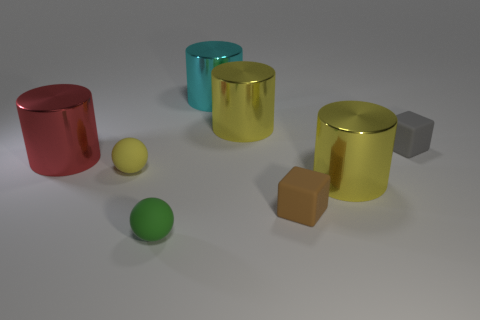There is a thing that is both in front of the tiny yellow object and on the right side of the brown block; what size is it?
Provide a short and direct response. Large. Are the green ball and the tiny yellow thing made of the same material?
Ensure brevity in your answer.  Yes. There is another matte thing that is the same shape as the tiny green object; what is its size?
Provide a short and direct response. Small. What color is the other matte object that is the same shape as the brown matte thing?
Your answer should be compact. Gray. There is a big yellow cylinder that is behind the red thing; what is it made of?
Provide a succinct answer. Metal. There is a yellow rubber object that is behind the brown rubber object; is it the same size as the big red shiny object?
Provide a short and direct response. No. What material is the large red cylinder on the left side of the yellow shiny cylinder to the right of the cube in front of the gray object made of?
Your answer should be very brief. Metal. There is a large metal cylinder that is on the right side of the small brown rubber thing; is it the same color as the block that is left of the tiny gray rubber thing?
Ensure brevity in your answer.  No. What material is the big object that is behind the yellow thing behind the gray thing?
Keep it short and to the point. Metal. The rubber ball that is the same size as the green rubber thing is what color?
Your answer should be very brief. Yellow. 